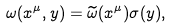<formula> <loc_0><loc_0><loc_500><loc_500>\omega ( x ^ { \mu } , y ) = \widetilde { \omega } ( x ^ { \mu } ) \sigma ( y ) ,</formula> 